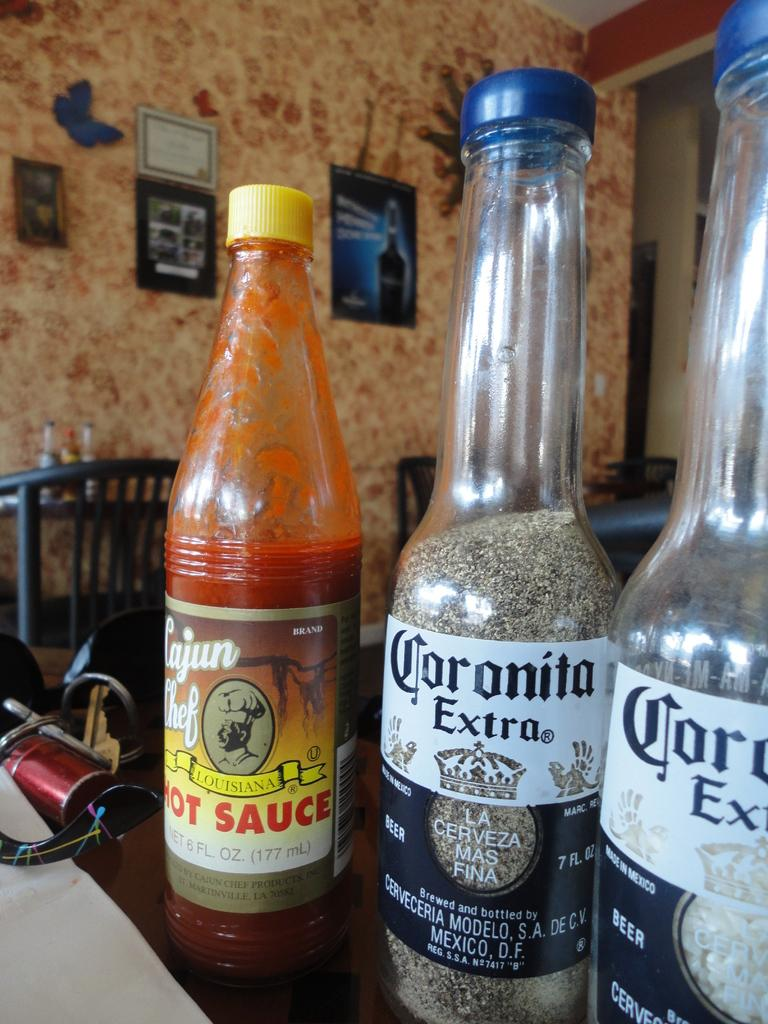<image>
Write a terse but informative summary of the picture. a jar of Cajun Chef Hot Sauce and Coronita Extra jars full of salt and pepper on a table 